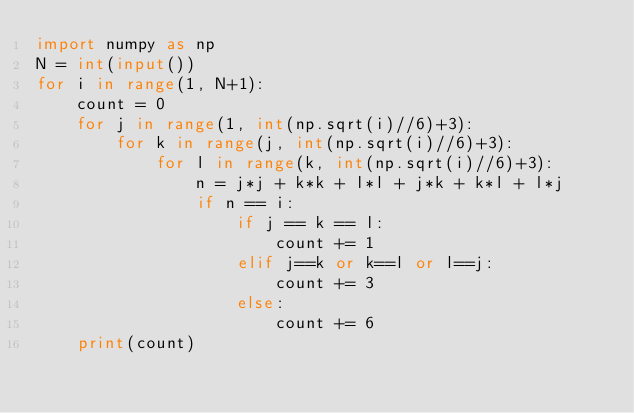<code> <loc_0><loc_0><loc_500><loc_500><_Python_>import numpy as np
N = int(input())
for i in range(1, N+1):
    count = 0
    for j in range(1, int(np.sqrt(i)//6)+3):
        for k in range(j, int(np.sqrt(i)//6)+3):
            for l in range(k, int(np.sqrt(i)//6)+3):
                n = j*j + k*k + l*l + j*k + k*l + l*j
                if n == i:
                    if j == k == l:
                        count += 1
                    elif j==k or k==l or l==j:
                        count += 3
                    else:
                        count += 6
    print(count)    
</code> 